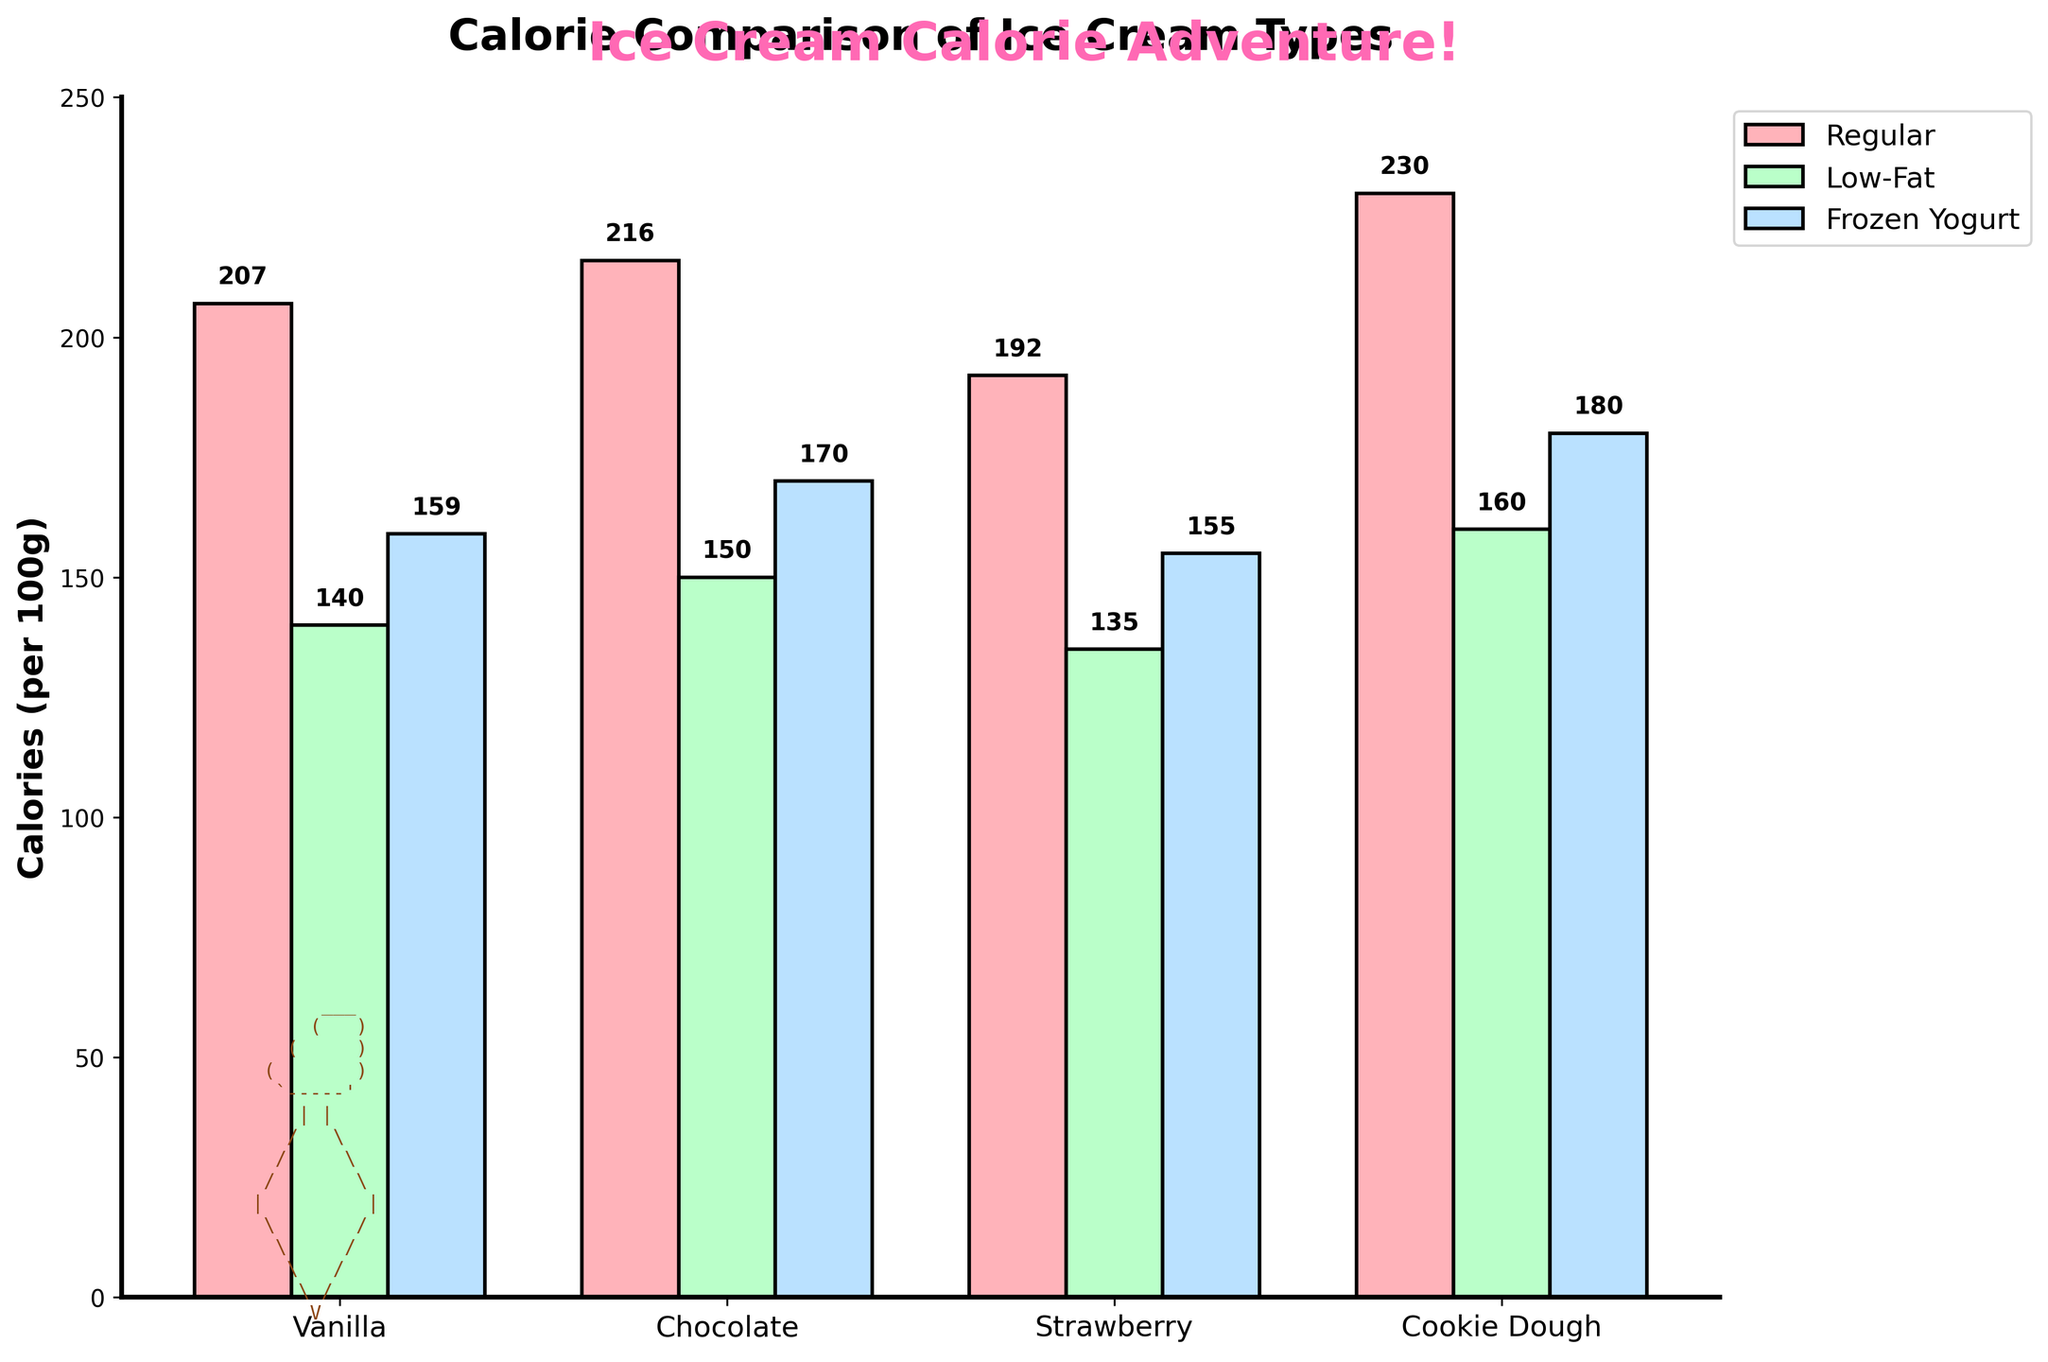What ice cream type has the highest calories? 'Regular Cookie Dough' has the tallest bar among all types of ice cream, indicating the highest calorie content of 230 calories per 100g.
Answer: Regular Cookie Dough How many more calories does Regular Chocolate have compared to Low-Fat Vanilla? Regular Chocolate has 216 calories, and Low-Fat Vanilla has 140 calories. The difference in calories is 216 - 140.
Answer: 76 Which ice cream type has the lowest calories? The shortest bar on the chart belongs to 'Low-Fat Strawberry' with 135 calories per 100g.
Answer: Low-Fat Strawberry Are Frozen Yogurt types generally higher in calories than Low-Fat types? Comparing the height of Frozen Yogurt bars to Low-Fat bars, Frozen Yogurt types are higher in calories per each flavor group.
Answer: Yes What is the average calorie content of all Vanilla ice creams? Regular Vanilla: 207, Low-Fat Vanilla: 140, Frozen Yogurt Vanilla: 159. The average is (207 + 140 + 159) / 3.
Answer: 169 Which has more calories, Frozen Yogurt Chocolate or Frozen Yogurt Vanilla? Frozen Yogurt Chocolate has a taller bar than Frozen Yogurt Vanilla, indicating 170 calories compared to 159 calories.
Answer: Frozen Yogurt Chocolate How does Low-Fat Cookie Dough compare to Regular Cookie Dough in calorie content? Regular Cookie Dough has 230 calories, and Low-Fat Cookie Dough has 160 calories, so Regular Cookie Dough has significantly more calories.
Answer: Regular Cookie Dough has more What's the difference in calories between Regular and Low-Fat Strawberry ice cream? Regular Strawberry has 192 calories, and Low-Fat Strawberry has 135 calories. The difference is 192 - 135.
Answer: 57 Which ice cream type shows the highest calorie content in the Frozen Yogurt category? By observing the tallest bar in the Frozen Yogurt category, 'Frozen Yogurt Cookie Dough' has the highest calorie content of 180 calories per 100g in this category.
Answer: Frozen Yogurt Cookie Dough Is Regular Vanilla higher in calories than Frozen Yogurt Cookie Dough? Regular Vanilla has 207 calories, and Frozen Yogurt Cookie Dough has 180 calories. Regular Vanilla has more calories.
Answer: Yes 